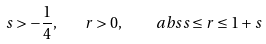<formula> <loc_0><loc_0><loc_500><loc_500>s > - \frac { 1 } { 4 } , \quad r > 0 , \quad \ a b s { s } \leq r \leq 1 + s</formula> 